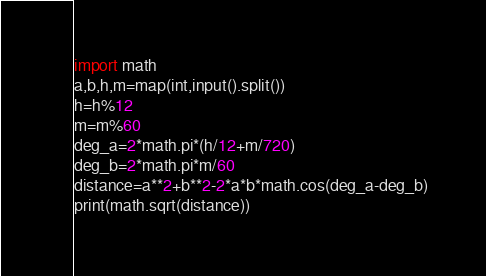Convert code to text. <code><loc_0><loc_0><loc_500><loc_500><_Python_>import math
a,b,h,m=map(int,input().split())
h=h%12
m=m%60
deg_a=2*math.pi*(h/12+m/720)
deg_b=2*math.pi*m/60
distance=a**2+b**2-2*a*b*math.cos(deg_a-deg_b)
print(math.sqrt(distance))</code> 